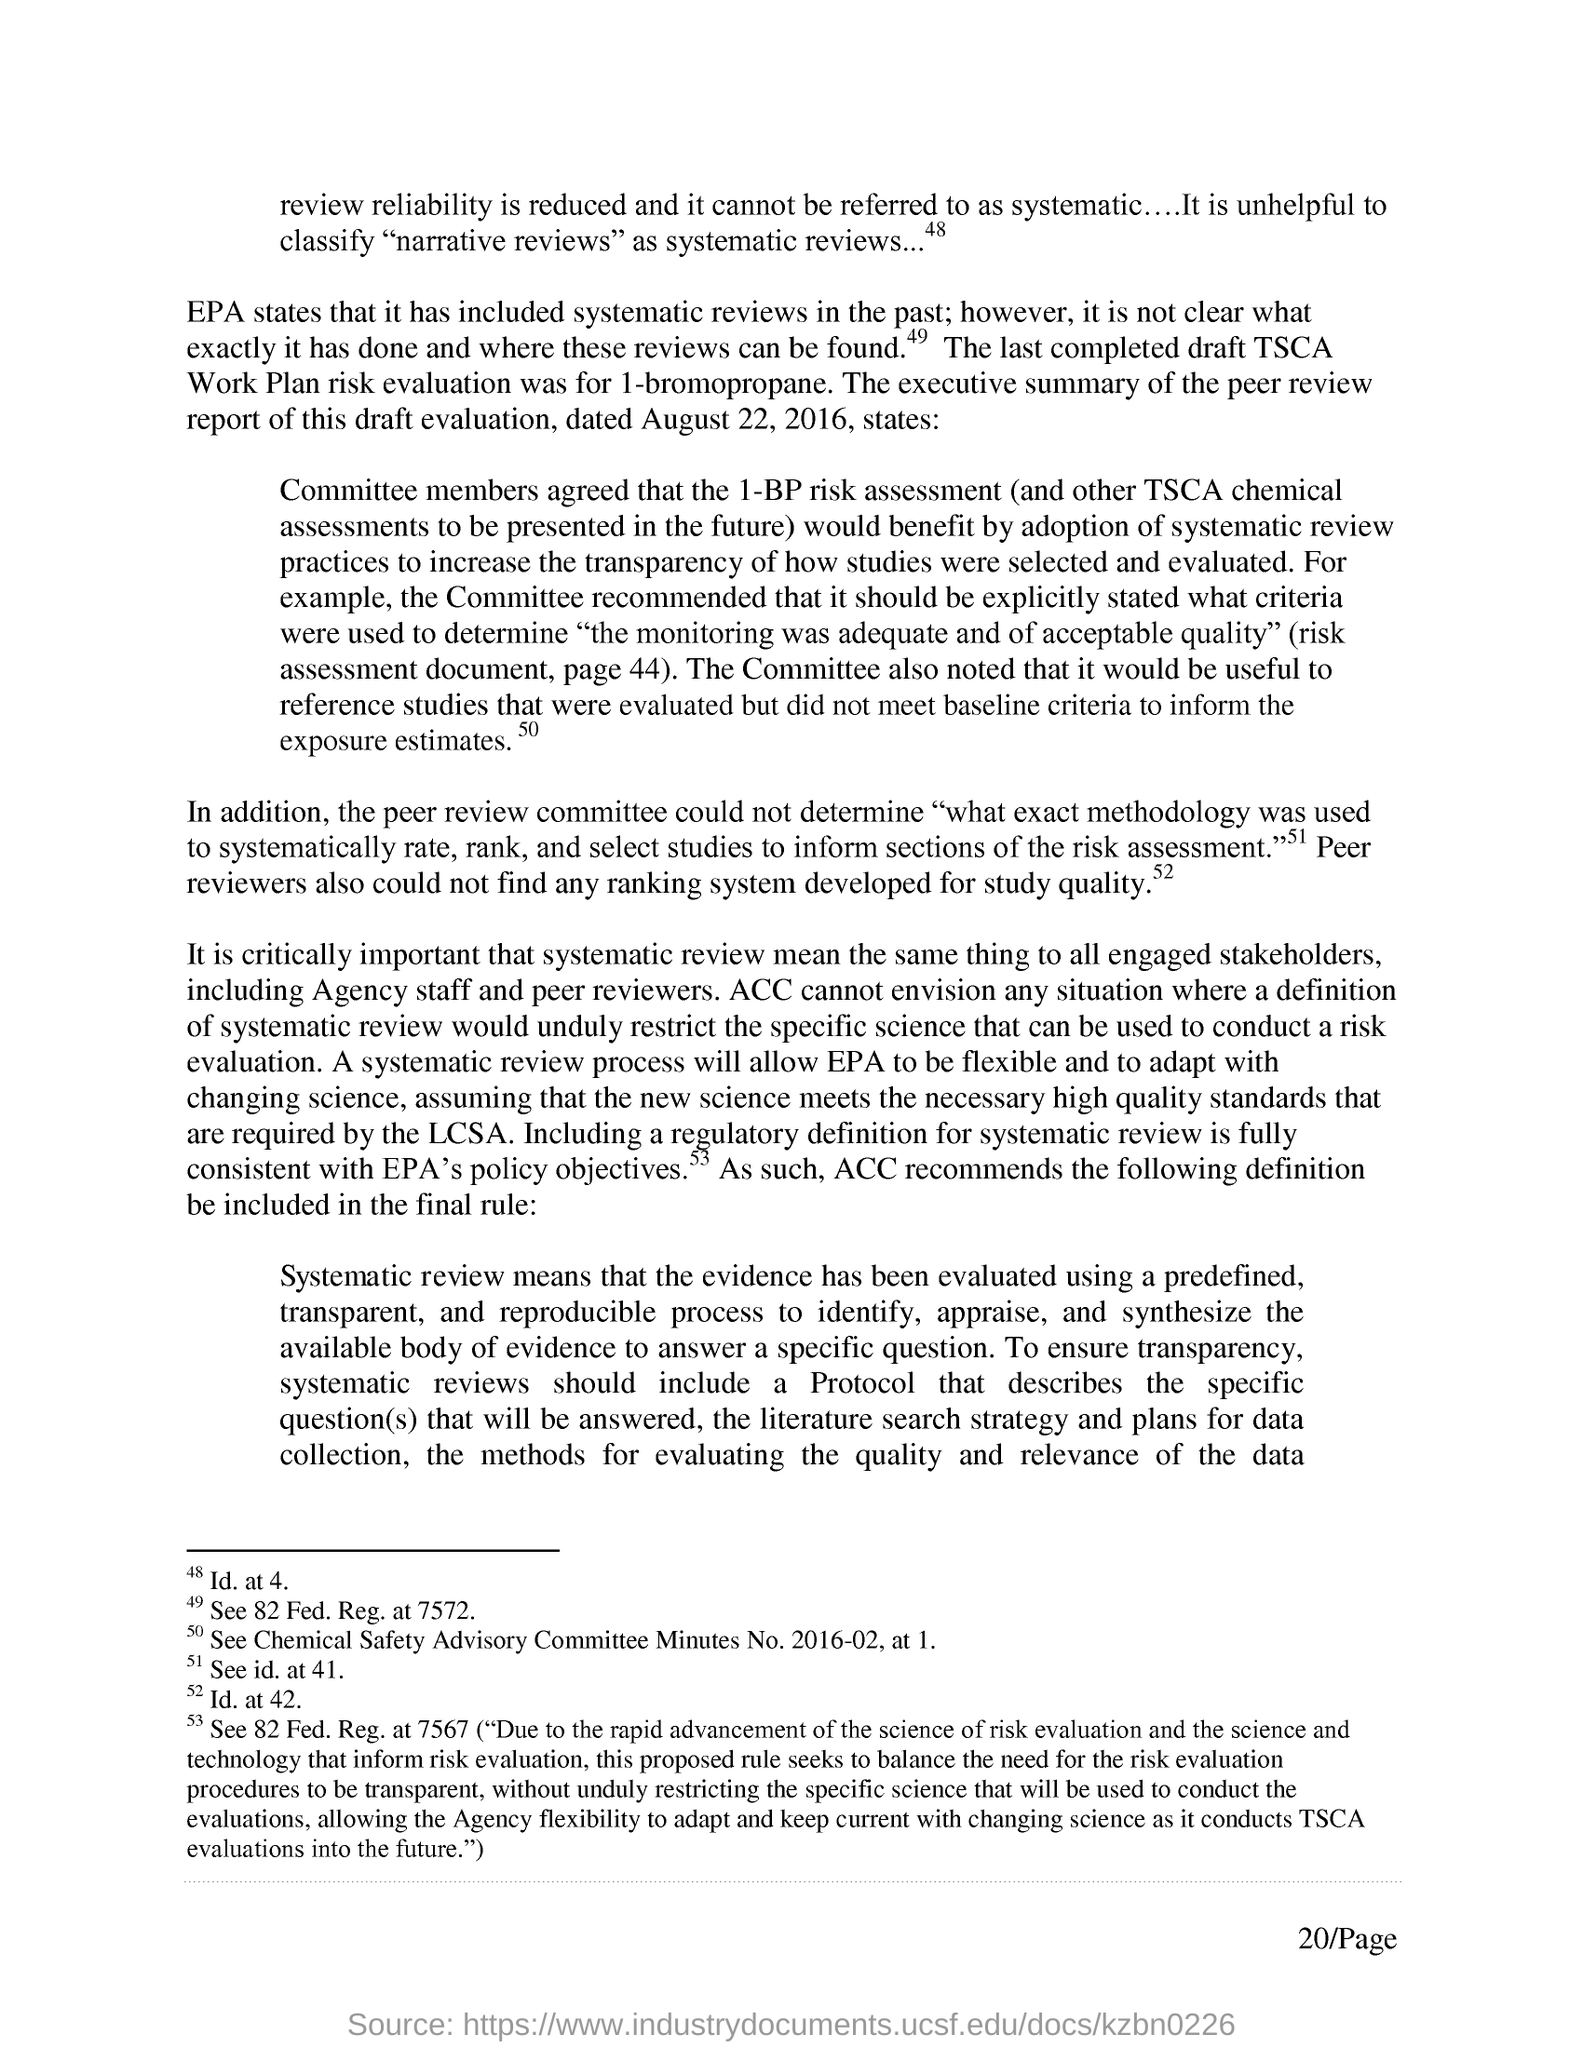Highlight a few significant elements in this photo. The peer review report of the draft evaluation was dated August 22, 2016. The TSCA Workplan Risk Evaluation for 1-bromopropane was completed using a component. 